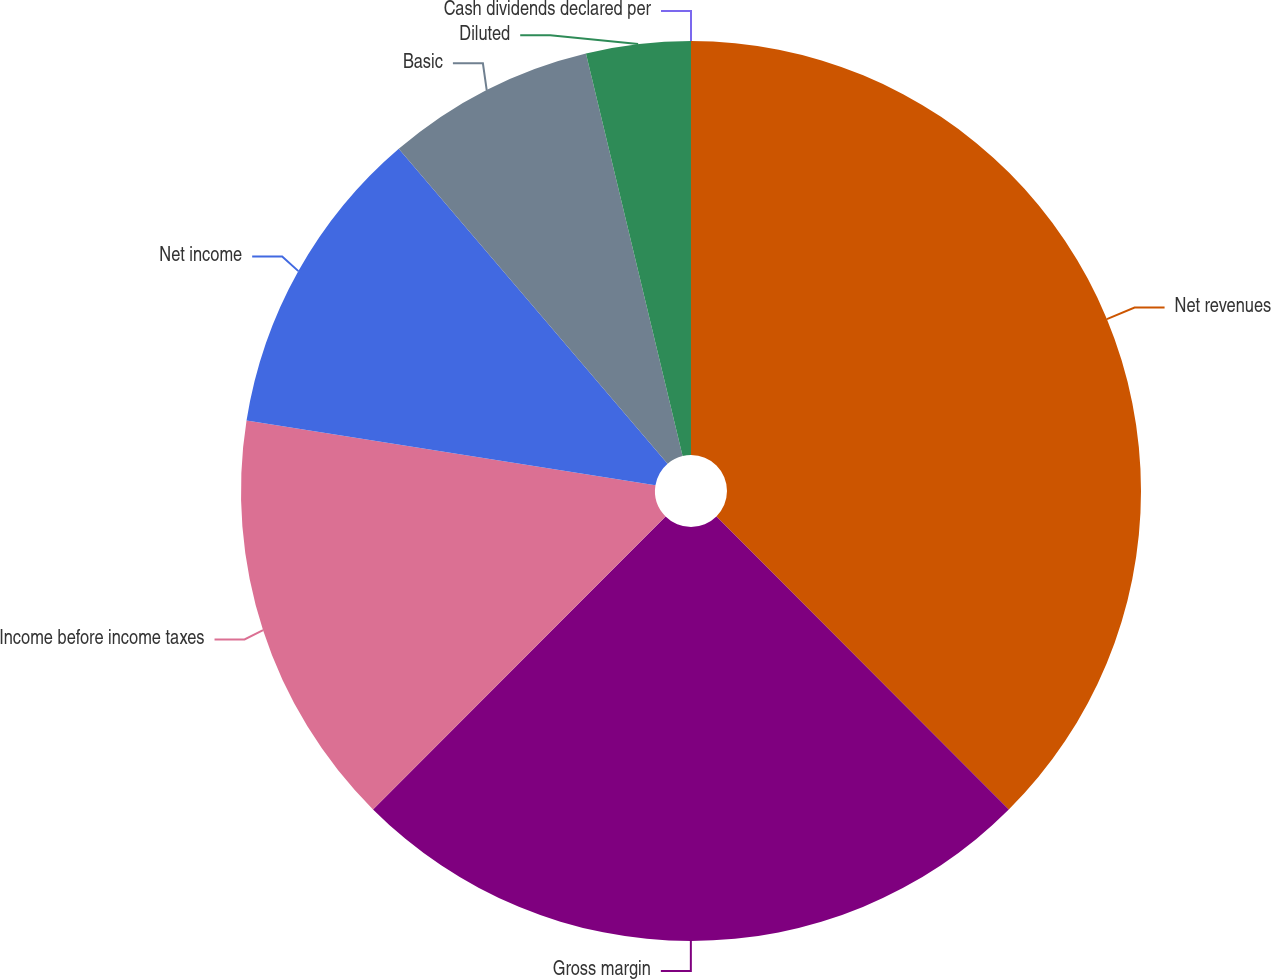<chart> <loc_0><loc_0><loc_500><loc_500><pie_chart><fcel>Net revenues<fcel>Gross margin<fcel>Income before income taxes<fcel>Net income<fcel>Basic<fcel>Diluted<fcel>Cash dividends declared per<nl><fcel>37.52%<fcel>24.97%<fcel>15.01%<fcel>11.25%<fcel>7.5%<fcel>3.75%<fcel>0.0%<nl></chart> 